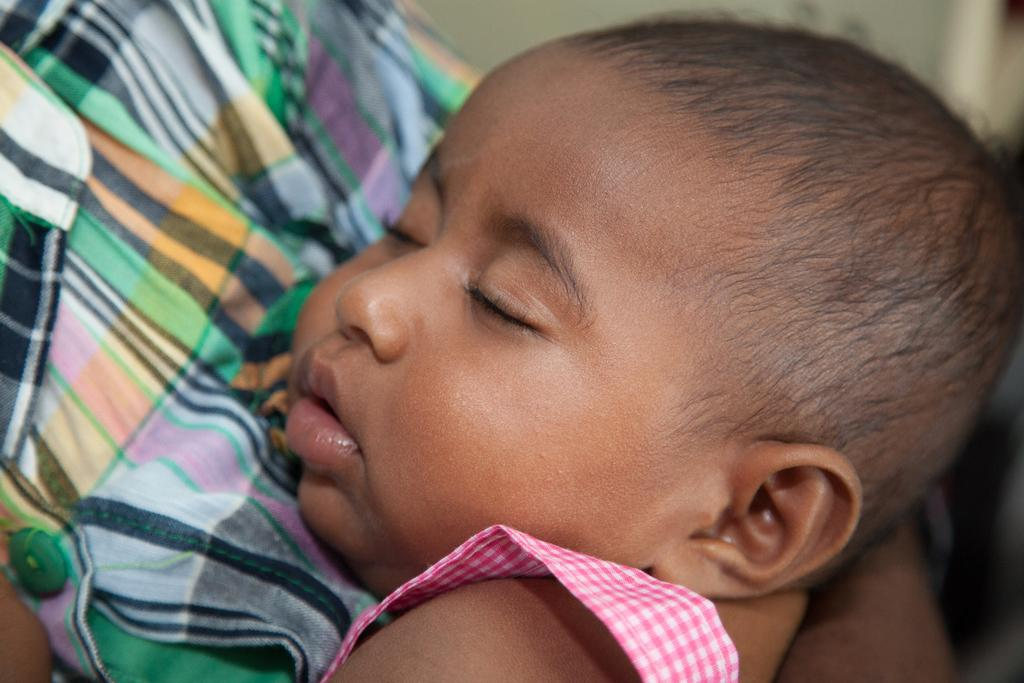What is the main subject of the image? There is a kid sleeping in the image. Can you describe the other person in the image? There is another person on the left side of the image. What can be said about the background of the image? The background of the image is blurry. What type of legal advice is the kitten providing in the image? There is no kitten present in the image, and therefore no legal advice can be provided. 